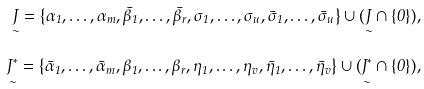Convert formula to latex. <formula><loc_0><loc_0><loc_500><loc_500>\underset { \sim } { J } = \left \{ \alpha _ { 1 } , \dots , \alpha _ { m } , \bar { \beta } _ { 1 } , \dots , \bar { \beta } _ { r } , \sigma _ { 1 } , \dots , \sigma _ { u } , \bar { \sigma } _ { 1 } , \dots , \bar { \sigma } _ { u } \right \} \cup ( \underset { \sim } { J } \cap \{ 0 \} ) , \\ \underset { \sim } { J ^ { * } } = \left \{ \bar { \alpha } _ { 1 } , \dots , \bar { \alpha } _ { m } , \beta _ { 1 } , \dots , \beta _ { r } , \eta _ { 1 } , \dots , \eta _ { v } , \bar { \eta } _ { 1 } , \dots , \bar { \eta } _ { v } \right \} \cup ( \underset { \sim } { J ^ { * } } \cap \{ 0 \} ) ,</formula> 